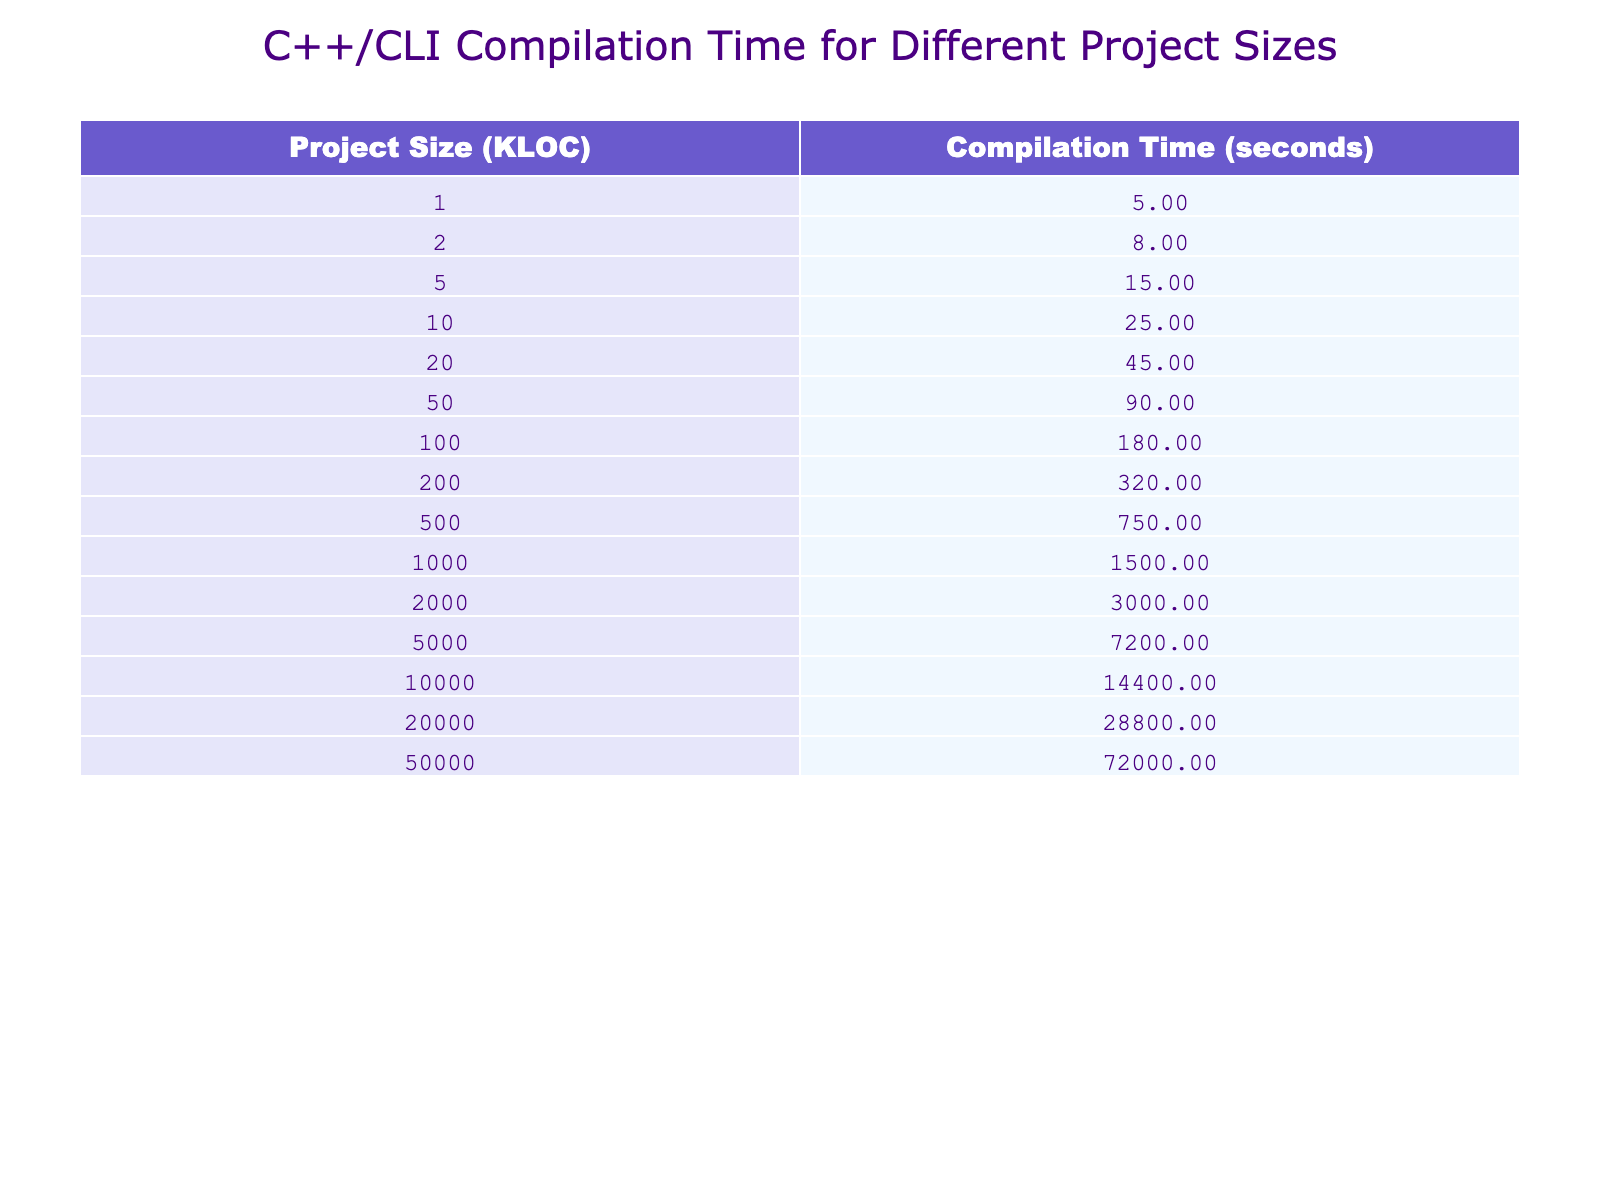What is the compilation time for a project size of 10 KLOC? According to the table, the compilation time listed for a project size of 10 KLOC is 25 seconds.
Answer: 25 seconds How much longer does it take to compile a 1000 KLOC project compared to a 200 KLOC project? The compilation time for a 1000 KLOC project is 1500 seconds and for a 200 KLOC project, it is 320 seconds. The difference is 1500 - 320 = 1180 seconds.
Answer: 1180 seconds What is the total compilation time for projects of size 1 KLOC and 2 KLOC combined? The compilation time for 1 KLOC is 5 seconds and for 2 KLOC is 8 seconds. Adding these gives us 5 + 8 = 13 seconds.
Answer: 13 seconds Is the compilation time for a 500 KLOC project less than the compilation time for a 2000 KLOC project? The compilation time for a 500 KLOC project is 750 seconds, while for a 2000 KLOC project, it is 3000 seconds. Since 750 is less than 3000, the statement is true.
Answer: Yes What is the average compilation time for project sizes of 20 KLOC and 50 KLOC? The compilation times for 20 KLOC and 50 KLOC are 45 seconds and 90 seconds respectively. The average can be calculated as (45 + 90) / 2 = 67.5 seconds.
Answer: 67.5 seconds If a project size of 5000 KLOC is added to the existing compilation times, how many project sizes would have a compilation time greater than 5000 seconds? The compilation time for the 5000 KLOC project is 7200 seconds. Looking through the table, the project sizes with greater compilation times are 10000 KLOC (14400 seconds), 20000 KLOC (28800 seconds), and 50000 KLOC (72000 seconds). Therefore, there are 3 project sizes greater than 5000 seconds.
Answer: 3 What is the difference in compilation time between the largest and smallest project sizes in the table? The smallest project size in the table is 1 KLOC with a compilation time of 5 seconds and the largest is 50000 KLOC with a compilation time of 72000 seconds. The difference is 72000 - 5 = 71995 seconds.
Answer: 71995 seconds How is the change in compilation time from 100 KLOC to 200 KLOC characterized? The compilation time for 100 KLOC is 180 seconds while for 200 KLOC it is 320 seconds. The change is 320 - 180 = 140 seconds, indicating an increase in compilation time.
Answer: Increase of 140 seconds Are there any project sizes under 10 KLOC with compilation times exceeding 30 seconds? The project sizes under 10 KLOC are 1 KLOC, 2 KLOC, 5 KLOC, and 10 KLOC. Their compilation times are 5 seconds, 8 seconds, 15 seconds, and 25 seconds respectively, all of which do not exceed 30 seconds.
Answer: No What multiplier would you use to get the compilation time of a 20000 KLOC project compared to a 1000 KLOC project? The compilation time for a 20000 KLOC project is 28800 seconds and for a 1000 KLOC project, it is 1500 seconds. To find the multiplier, we divide 28800 by 1500: 28800 / 1500 = 19.2.
Answer: 19.2 